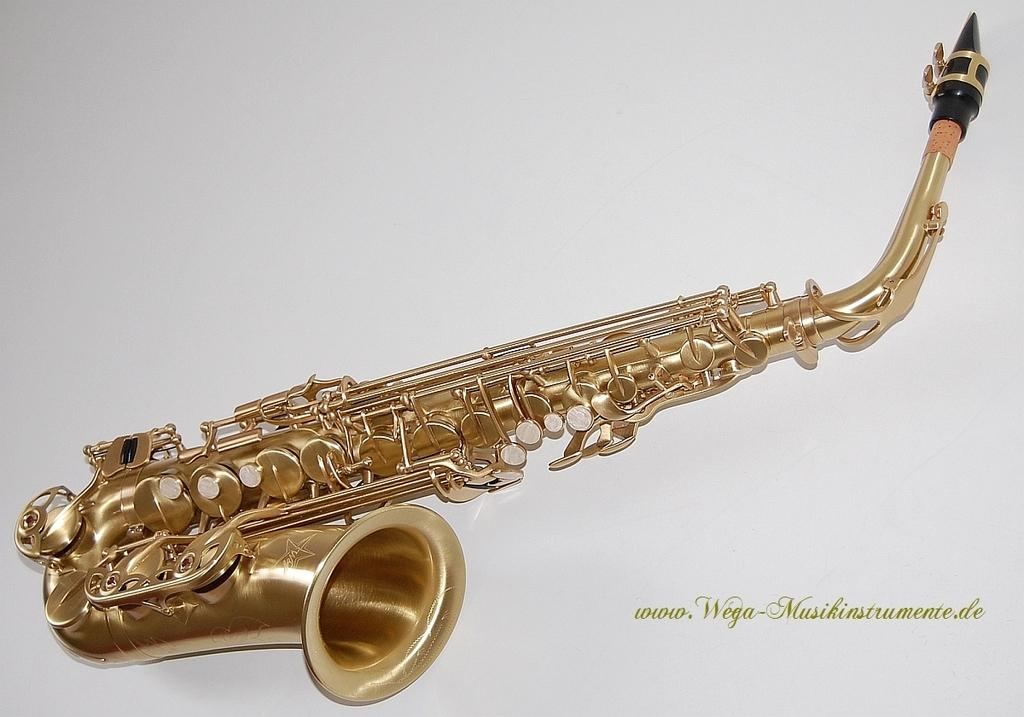What musical instrument is present in the image? There is a saxophone in the image. Is there any text associated with the image? Yes, there is text at the bottom of the image. How many snails can be seen crawling on the saxophone in the image? There are no snails present in the image; it only features a saxophone and text. What type of rice is being cooked in the background of the image? There is no rice visible in the image, as it only contains a saxophone and text. 